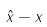Convert formula to latex. <formula><loc_0><loc_0><loc_500><loc_500>\hat { x } - x</formula> 